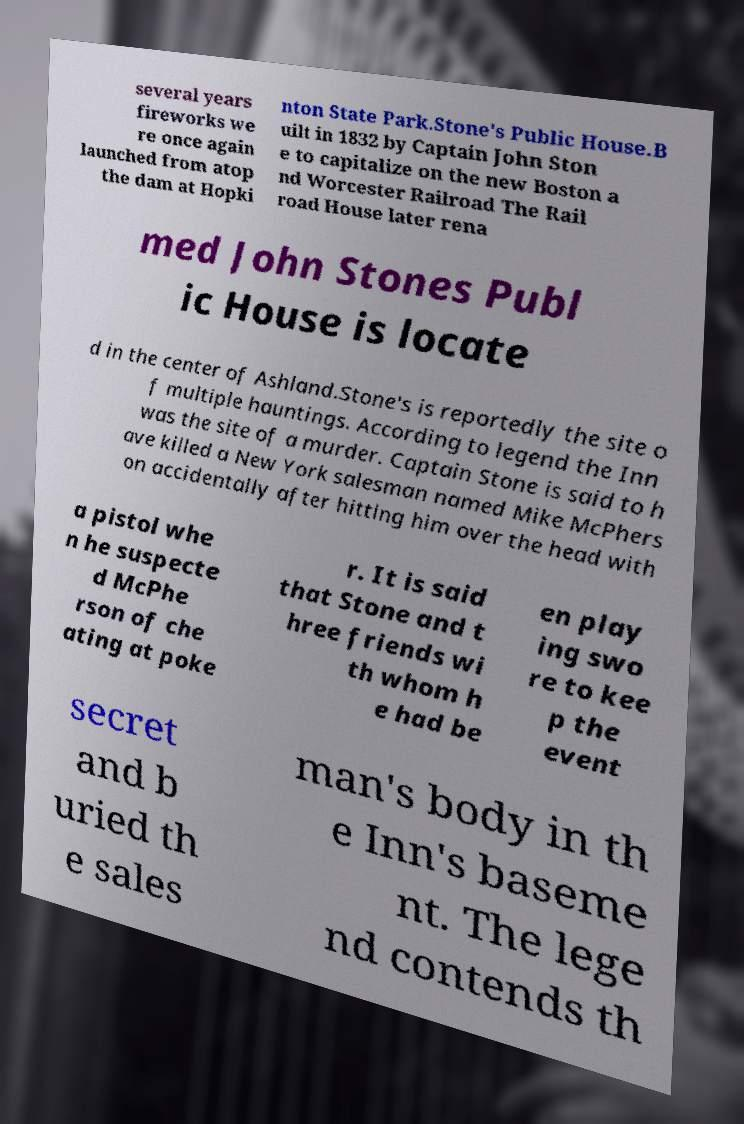Can you accurately transcribe the text from the provided image for me? several years fireworks we re once again launched from atop the dam at Hopki nton State Park.Stone's Public House.B uilt in 1832 by Captain John Ston e to capitalize on the new Boston a nd Worcester Railroad The Rail road House later rena med John Stones Publ ic House is locate d in the center of Ashland.Stone's is reportedly the site o f multiple hauntings. According to legend the Inn was the site of a murder. Captain Stone is said to h ave killed a New York salesman named Mike McPhers on accidentally after hitting him over the head with a pistol whe n he suspecte d McPhe rson of che ating at poke r. It is said that Stone and t hree friends wi th whom h e had be en play ing swo re to kee p the event secret and b uried th e sales man's body in th e Inn's baseme nt. The lege nd contends th 